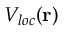<formula> <loc_0><loc_0><loc_500><loc_500>V _ { l o c } ( { r } )</formula> 